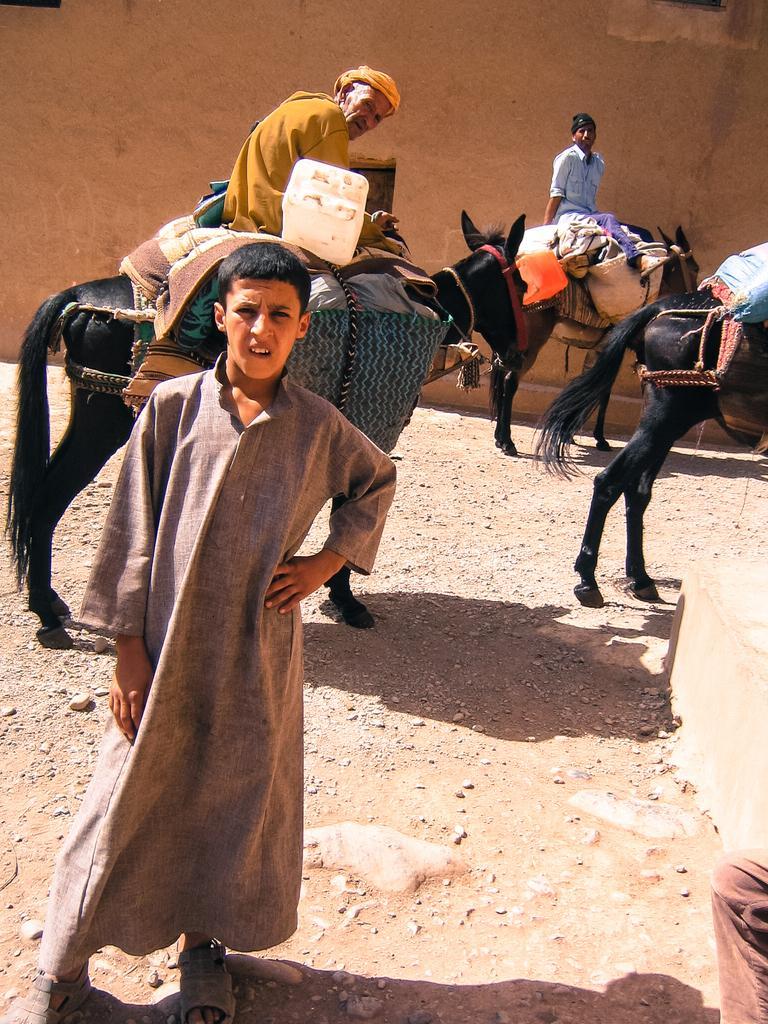How would you summarize this image in a sentence or two? This is a picture of a man standing and man sitting in the horse ,another person sitting in the horse, an another horse and in back ground we have a wall. 